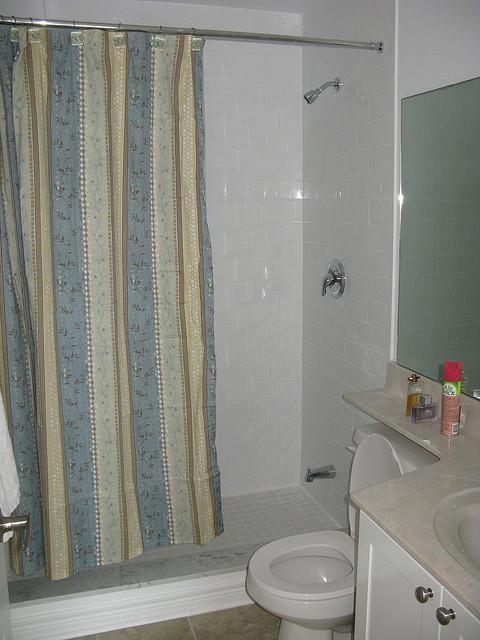How many bottles are in the shower?
Give a very brief answer. 0. 